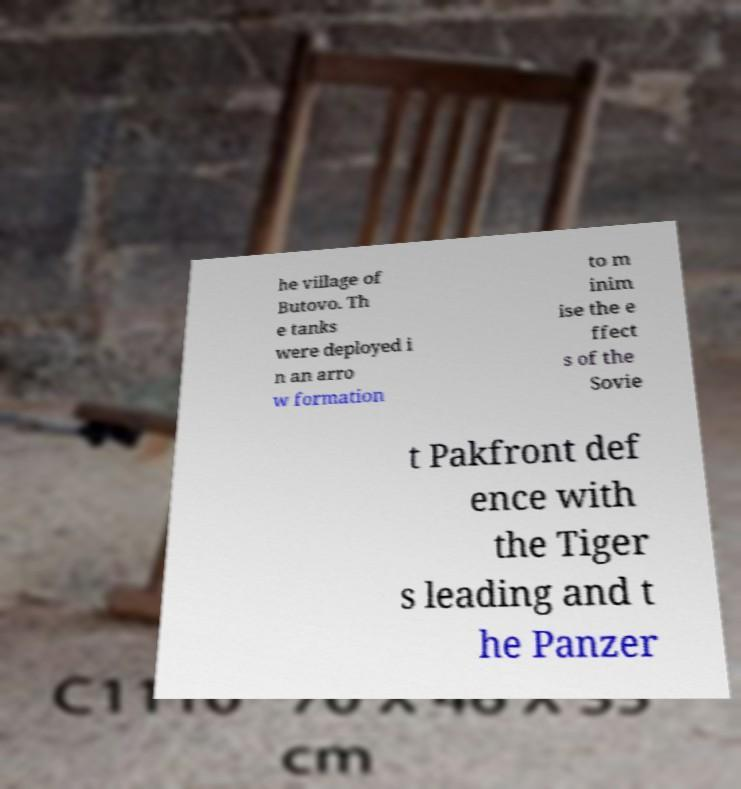Can you accurately transcribe the text from the provided image for me? he village of Butovo. Th e tanks were deployed i n an arro w formation to m inim ise the e ffect s of the Sovie t Pakfront def ence with the Tiger s leading and t he Panzer 